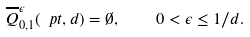<formula> <loc_0><loc_0><loc_500><loc_500>\overline { Q } _ { 0 , 1 } ^ { \epsilon } ( \ p t , d ) = \emptyset , \quad 0 < \epsilon \leq 1 / d .</formula> 